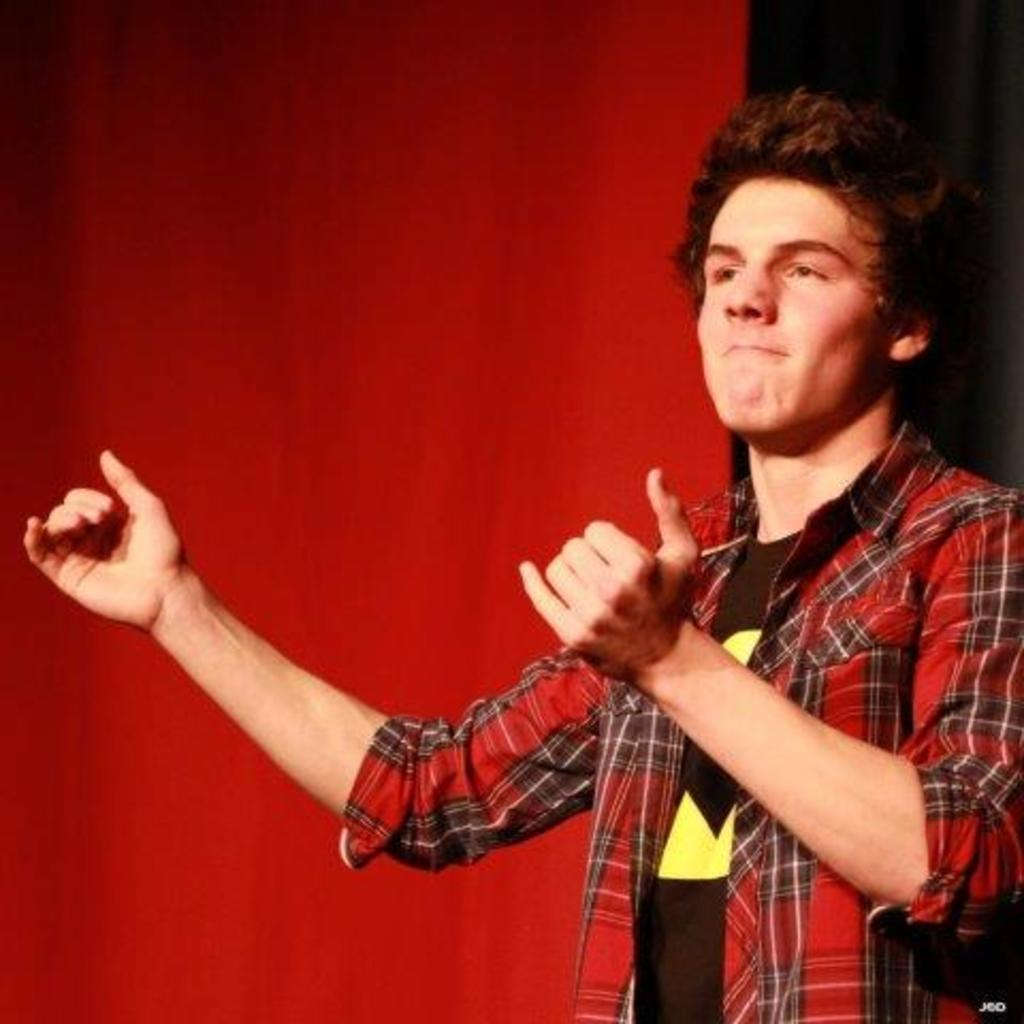What is the main subject of the image? There is a man in the image. What is the man wearing on his upper body? The man is wearing a black T-shirt and a red check shirt. What is the man's posture in the image? The man is standing. What is the color of the area behind the man? The area behind the man is black in color. What can be seen on the left side of the image? There is a red color sheet on the left side of the image. What type of plastic material is being developed in the image? There is no mention of plastic or development in the image; it features a man wearing a black T-shirt and a red check shirt, standing in front of a black background with a red color sheet on the left side. 